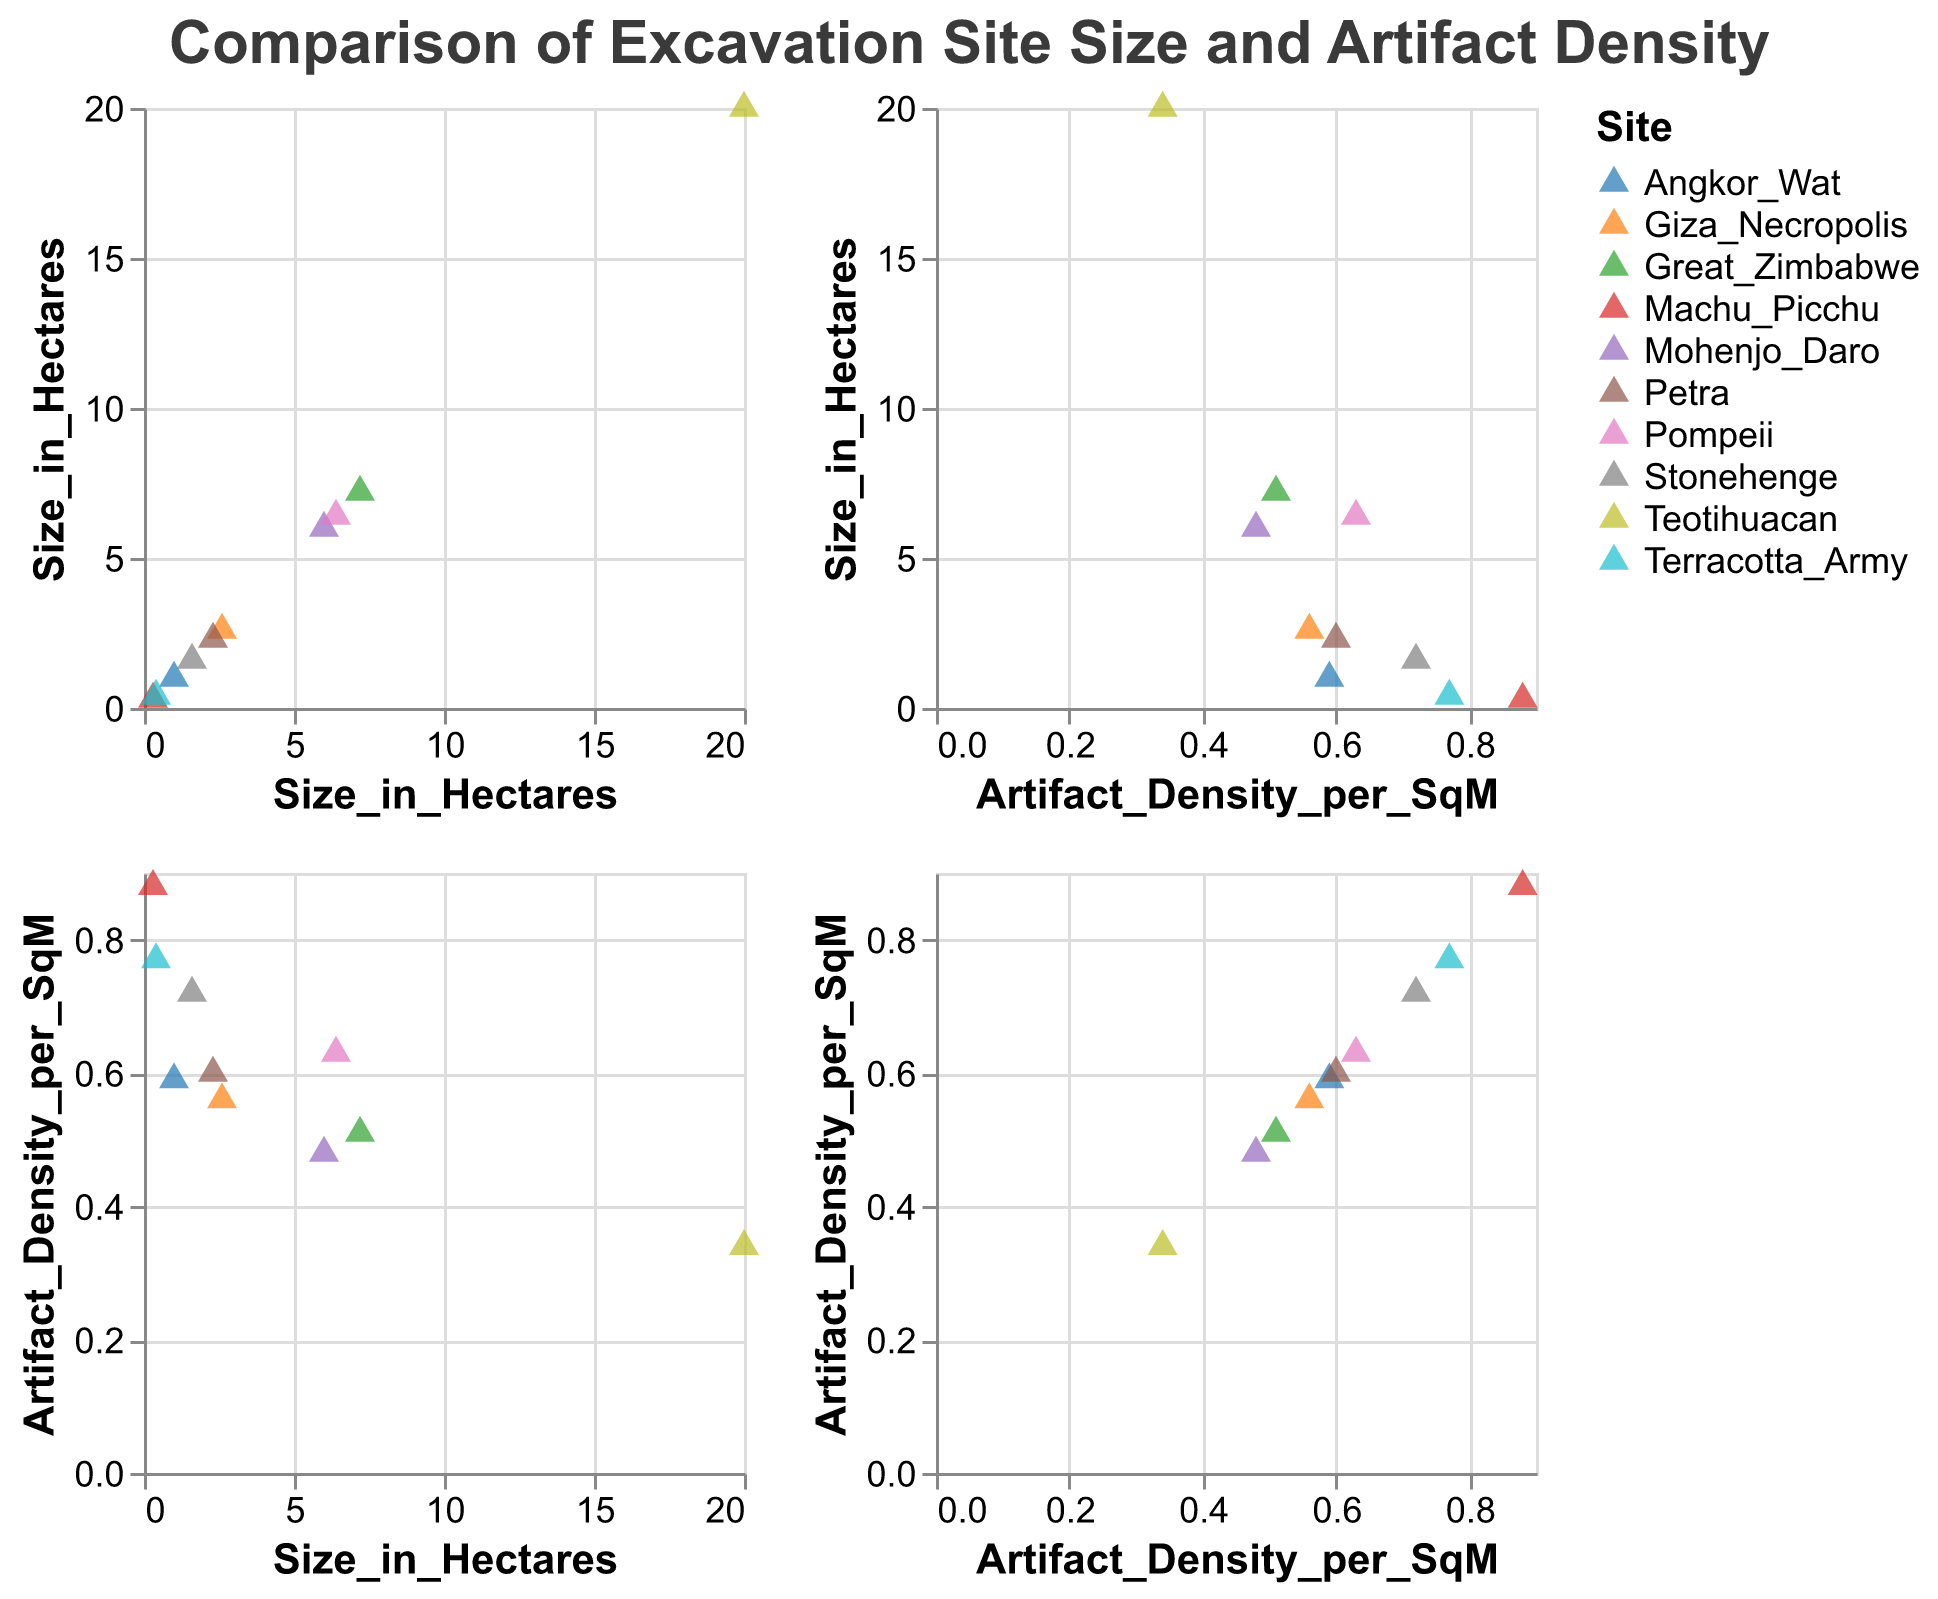What's the title of the figure? The title is mentioned at the top center of the figure in bold font
Answer: Comparison of Excavation Site Size and Artifact Density How many data points (archaeological sites) are represented in the figure? Count the individual points in the scatter plot matrix. Each point represents a unique site
Answer: 10 Which site has the highest artifact density per square meter? Look for the highest positioned point on the 'Artifact_Density_per_SqM' axis
Answer: Machu Picchu Which site has the largest size in hectares? Look for the furthest right point on the 'Size_in_Hectares' axis
Answer: Teotihuacan Is there a site that has both a small size in hectares and high artifact density? Check for points that are positioned to the left of the 'Size_in_Hectares' axis and high on the 'Artifact_Density_per_SqM' axis
Answer: Machu Picchu and Terracotta Army What is the average size in hectares of the sites with an artifact density greater than 0.6? Identify the sites with an artifact density greater than 0.6 and calculate their average size. Sites: Machu Picchu (0.3 ha), Pompeii (6.4 ha), Stonehenge (1.6 ha), Petra (2.3 ha), Terracotta Army (0.4 ha). Sum (0.3 + 6.4 + 1.6 + 2.3 + 0.4) = 11, Average = 11/5
Answer: 2.2 hectares Do any sites have the same artifact density? Look for points that align on the 'Artifact_Density_per_SqM' axis
Answer: No Which site has a lower artifact density: Giza Necropolis or Teotihuacan? Compare the positions of the points representing these two sites on the 'Artifact_Density_per_SqM' axis
Answer: Teotihuacan What is the approximate range of artifact densities? Identify the lowest and highest points on the 'Artifact_Density_per_SqM' axis. Lowest: Teotihuacan (0.34), Highest: Machu Picchu (0.88). Range = 0.88 - 0.34
Answer: 0.54 Is there an overall trend between the size of the sites and the artifact density? Observe the scatter plots to see if there is any apparent relationship or trend. In this case, larger sites do not consistently have higher or lower artifact densities; there seems to be a weak or no correlation
Answer: No clear trend 